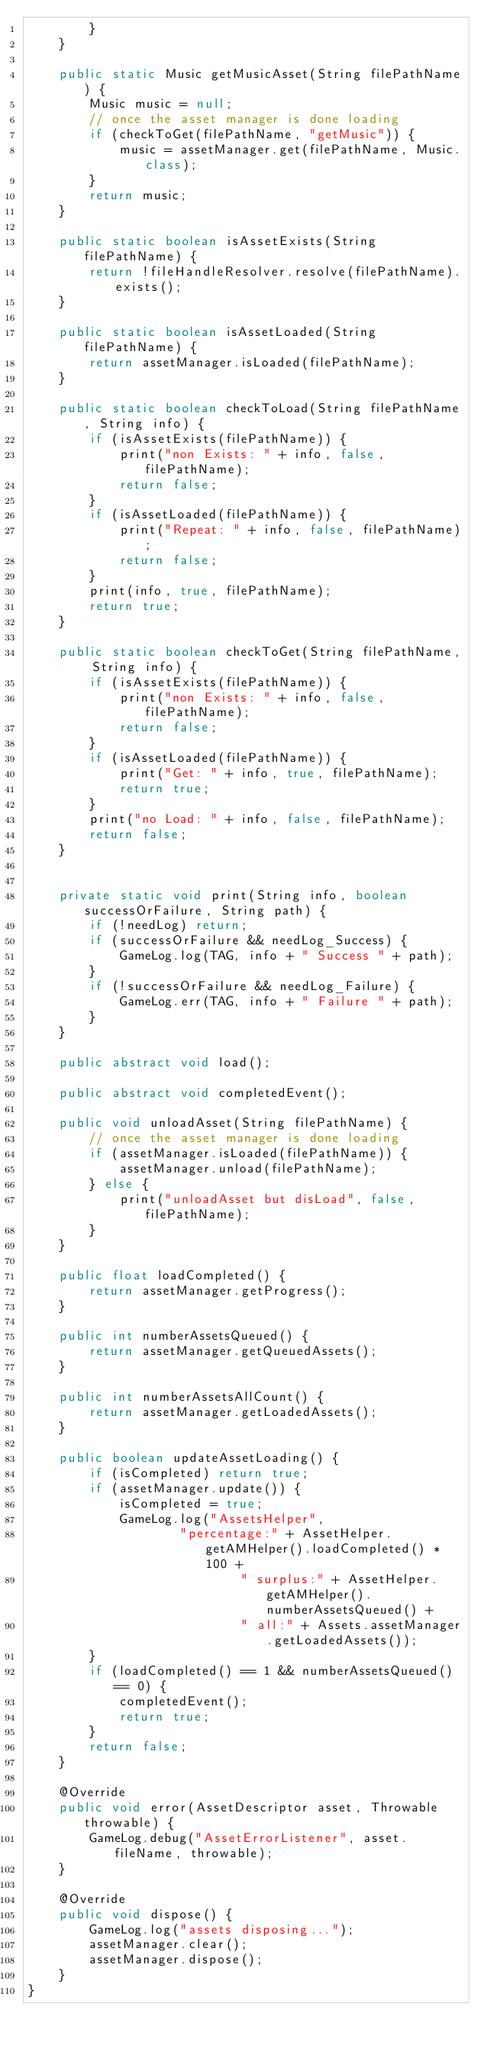Convert code to text. <code><loc_0><loc_0><loc_500><loc_500><_Java_>        }
    }

    public static Music getMusicAsset(String filePathName) {
        Music music = null;
        // once the asset manager is done loading
        if (checkToGet(filePathName, "getMusic")) {
            music = assetManager.get(filePathName, Music.class);
        }
        return music;
    }

    public static boolean isAssetExists(String filePathName) {
        return !fileHandleResolver.resolve(filePathName).exists();
    }

    public static boolean isAssetLoaded(String filePathName) {
        return assetManager.isLoaded(filePathName);
    }

    public static boolean checkToLoad(String filePathName, String info) {
        if (isAssetExists(filePathName)) {
            print("non Exists: " + info, false, filePathName);
            return false;
        }
        if (isAssetLoaded(filePathName)) {
            print("Repeat: " + info, false, filePathName);
            return false;
        }
        print(info, true, filePathName);
        return true;
    }

    public static boolean checkToGet(String filePathName, String info) {
        if (isAssetExists(filePathName)) {
            print("non Exists: " + info, false, filePathName);
            return false;
        }
        if (isAssetLoaded(filePathName)) {
            print("Get: " + info, true, filePathName);
            return true;
        }
        print("no Load: " + info, false, filePathName);
        return false;
    }


    private static void print(String info, boolean successOrFailure, String path) {
        if (!needLog) return;
        if (successOrFailure && needLog_Success) {
            GameLog.log(TAG, info + " Success " + path);
        }
        if (!successOrFailure && needLog_Failure) {
            GameLog.err(TAG, info + " Failure " + path);
        }
    }

    public abstract void load();

    public abstract void completedEvent();

    public void unloadAsset(String filePathName) {
        // once the asset manager is done loading
        if (assetManager.isLoaded(filePathName)) {
            assetManager.unload(filePathName);
        } else {
            print("unloadAsset but disLoad", false, filePathName);
        }
    }

    public float loadCompleted() {
        return assetManager.getProgress();
    }

    public int numberAssetsQueued() {
        return assetManager.getQueuedAssets();
    }

    public int numberAssetsAllCount() {
        return assetManager.getLoadedAssets();
    }

    public boolean updateAssetLoading() {
        if (isCompleted) return true;
        if (assetManager.update()) {
            isCompleted = true;
            GameLog.log("AssetsHelper",
                    "percentage:" + AssetHelper.getAMHelper().loadCompleted() * 100 +
                            " surplus:" + AssetHelper.getAMHelper().numberAssetsQueued() +
                            " all:" + Assets.assetManager.getLoadedAssets());
        }
        if (loadCompleted() == 1 && numberAssetsQueued() == 0) {
            completedEvent();
            return true;
        }
        return false;
    }

    @Override
    public void error(AssetDescriptor asset, Throwable throwable) {
        GameLog.debug("AssetErrorListener", asset.fileName, throwable);
    }

    @Override
    public void dispose() {
        GameLog.log("assets disposing...");
        assetManager.clear();
        assetManager.dispose();
    }
}
</code> 